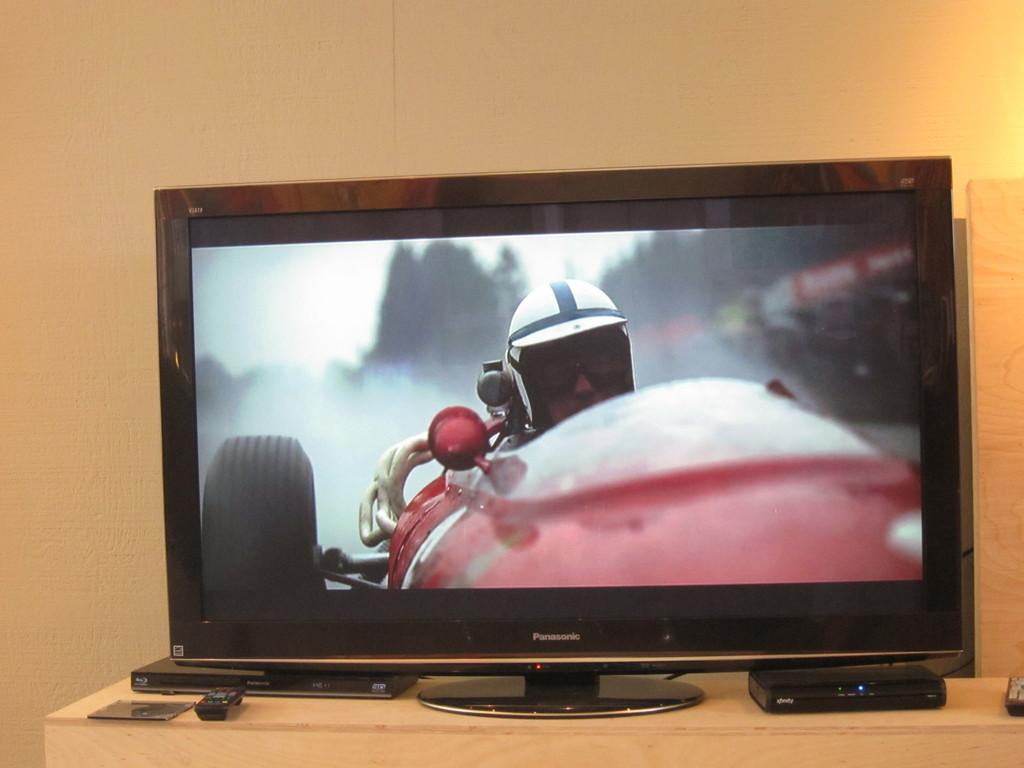<image>
Write a terse but informative summary of the picture. A Panasonic television is showing a race car driver. 